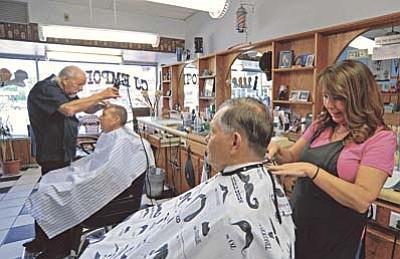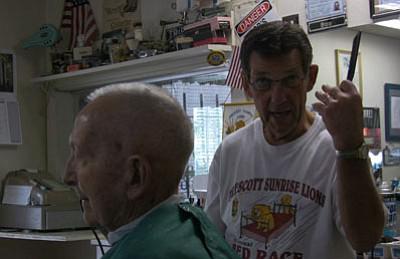The first image is the image on the left, the second image is the image on the right. Evaluate the accuracy of this statement regarding the images: "In one image, a male and a female barber are both working on seated customers, with an empty chair between them.". Is it true? Answer yes or no. No. 